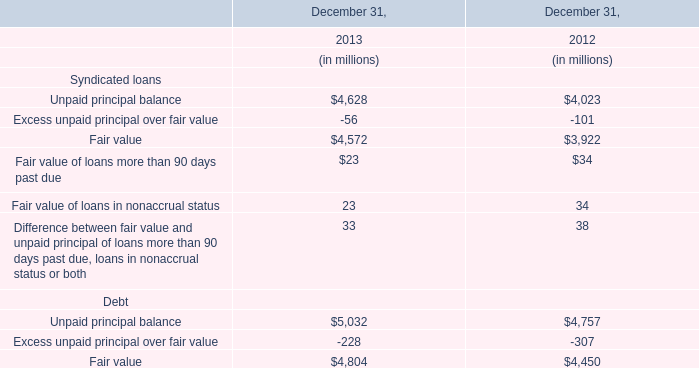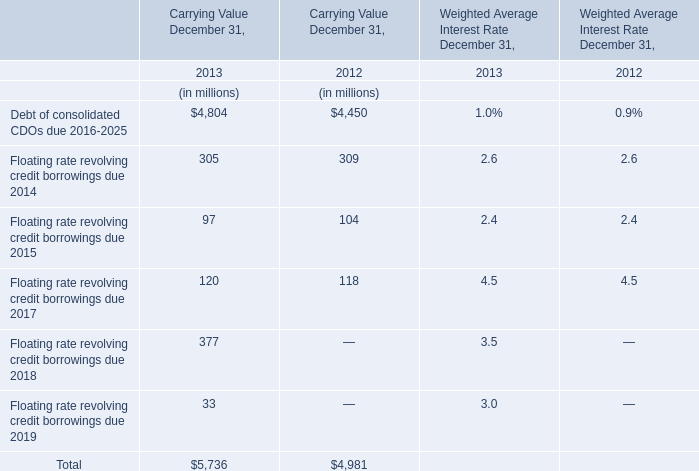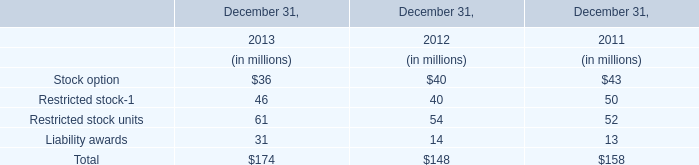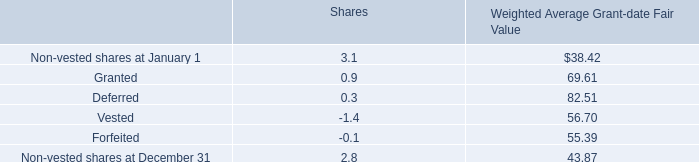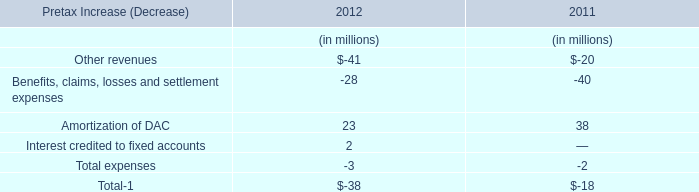Which year is carrying value of Floating rate revolving credit borrowings due 2014 the lowest? 
Answer: 2013. 